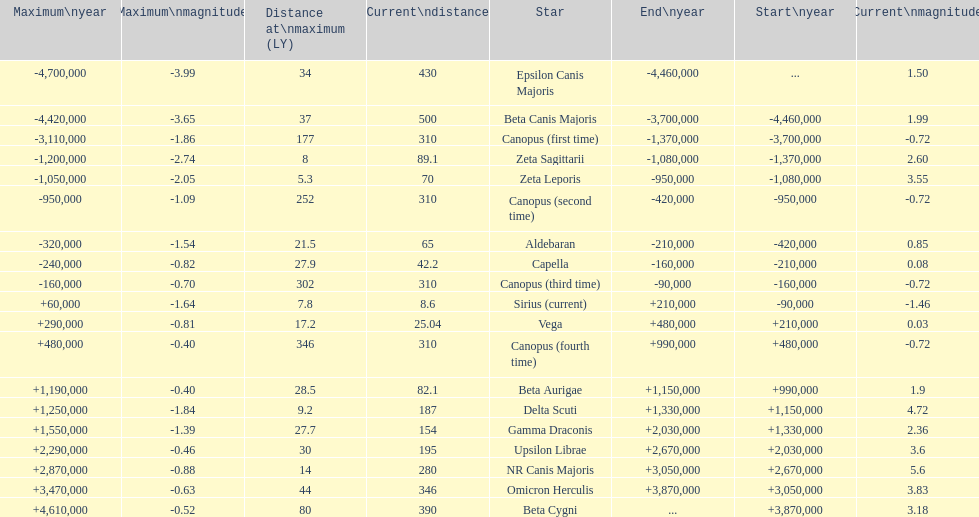How much farther (in ly) is epsilon canis majoris than zeta sagittarii? 26. Give me the full table as a dictionary. {'header': ['Maximum\\nyear', 'Maximum\\nmagnitude', 'Distance at\\nmaximum (LY)', 'Current\\ndistance', 'Star', 'End\\nyear', 'Start\\nyear', 'Current\\nmagnitude'], 'rows': [['-4,700,000', '-3.99', '34', '430', 'Epsilon Canis Majoris', '-4,460,000', '...', '1.50'], ['-4,420,000', '-3.65', '37', '500', 'Beta Canis Majoris', '-3,700,000', '-4,460,000', '1.99'], ['-3,110,000', '-1.86', '177', '310', 'Canopus (first time)', '-1,370,000', '-3,700,000', '-0.72'], ['-1,200,000', '-2.74', '8', '89.1', 'Zeta Sagittarii', '-1,080,000', '-1,370,000', '2.60'], ['-1,050,000', '-2.05', '5.3', '70', 'Zeta Leporis', '-950,000', '-1,080,000', '3.55'], ['-950,000', '-1.09', '252', '310', 'Canopus (second time)', '-420,000', '-950,000', '-0.72'], ['-320,000', '-1.54', '21.5', '65', 'Aldebaran', '-210,000', '-420,000', '0.85'], ['-240,000', '-0.82', '27.9', '42.2', 'Capella', '-160,000', '-210,000', '0.08'], ['-160,000', '-0.70', '302', '310', 'Canopus (third time)', '-90,000', '-160,000', '-0.72'], ['+60,000', '-1.64', '7.8', '8.6', 'Sirius (current)', '+210,000', '-90,000', '-1.46'], ['+290,000', '-0.81', '17.2', '25.04', 'Vega', '+480,000', '+210,000', '0.03'], ['+480,000', '-0.40', '346', '310', 'Canopus (fourth time)', '+990,000', '+480,000', '-0.72'], ['+1,190,000', '-0.40', '28.5', '82.1', 'Beta Aurigae', '+1,150,000', '+990,000', '1.9'], ['+1,250,000', '-1.84', '9.2', '187', 'Delta Scuti', '+1,330,000', '+1,150,000', '4.72'], ['+1,550,000', '-1.39', '27.7', '154', 'Gamma Draconis', '+2,030,000', '+1,330,000', '2.36'], ['+2,290,000', '-0.46', '30', '195', 'Upsilon Librae', '+2,670,000', '+2,030,000', '3.6'], ['+2,870,000', '-0.88', '14', '280', 'NR Canis Majoris', '+3,050,000', '+2,670,000', '5.6'], ['+3,470,000', '-0.63', '44', '346', 'Omicron Herculis', '+3,870,000', '+3,050,000', '3.83'], ['+4,610,000', '-0.52', '80', '390', 'Beta Cygni', '...', '+3,870,000', '3.18']]} 